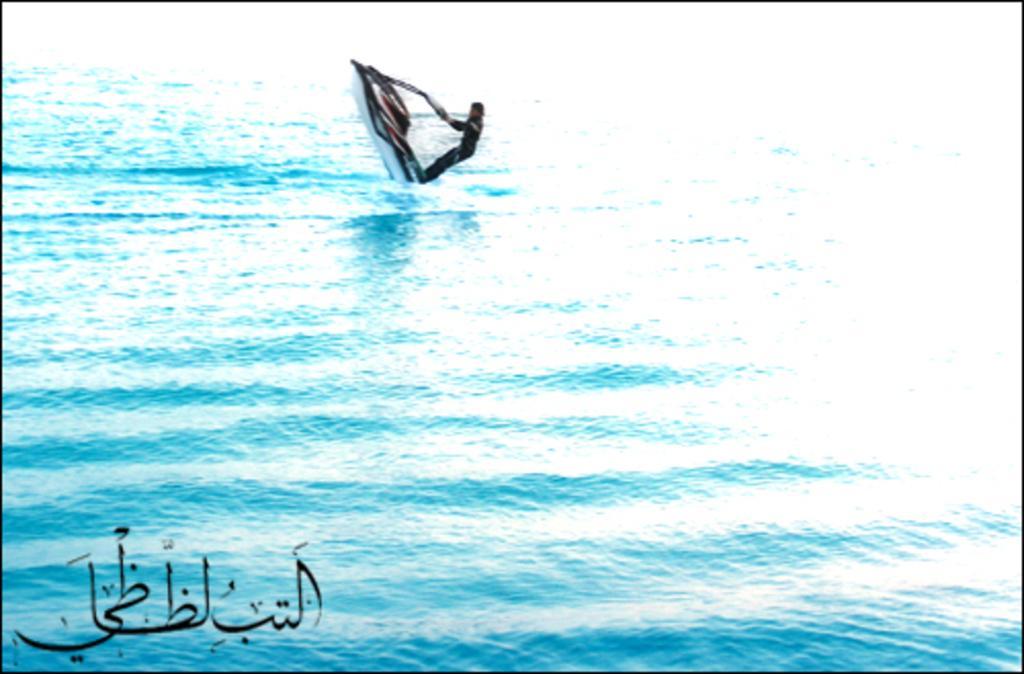How would you summarize this image in a sentence or two? In this image we can see water. On the water there is a jet boat. On that there is a person. In the left bottom corner something is written. 